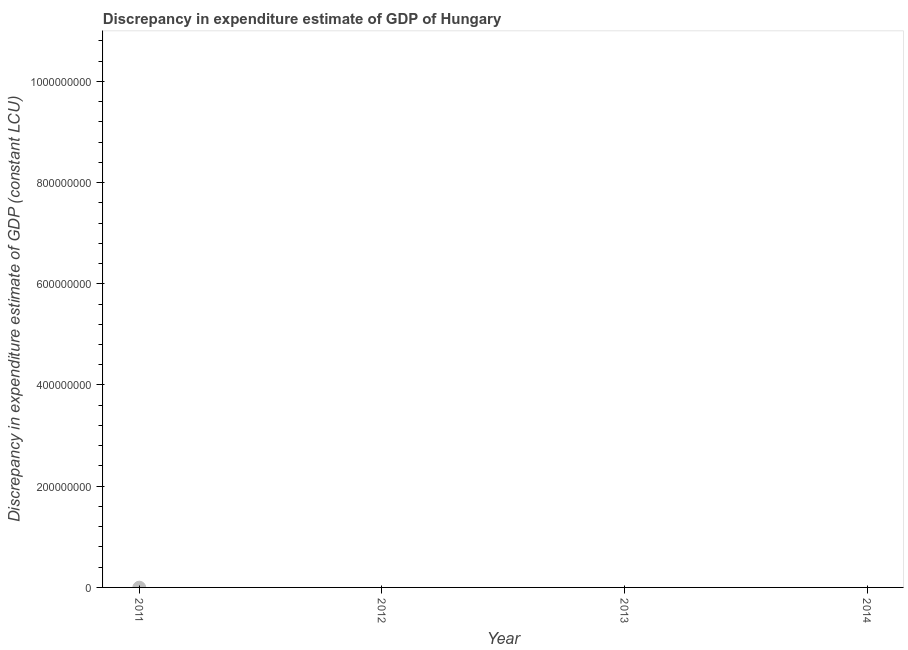Across all years, what is the minimum discrepancy in expenditure estimate of gdp?
Give a very brief answer. 0. What is the sum of the discrepancy in expenditure estimate of gdp?
Your answer should be compact. 0. What is the average discrepancy in expenditure estimate of gdp per year?
Your answer should be very brief. 0. What is the median discrepancy in expenditure estimate of gdp?
Your answer should be compact. 0. In how many years, is the discrepancy in expenditure estimate of gdp greater than the average discrepancy in expenditure estimate of gdp taken over all years?
Offer a very short reply. 0. How many dotlines are there?
Give a very brief answer. 0. What is the difference between two consecutive major ticks on the Y-axis?
Ensure brevity in your answer.  2.00e+08. Are the values on the major ticks of Y-axis written in scientific E-notation?
Keep it short and to the point. No. Does the graph contain any zero values?
Give a very brief answer. Yes. Does the graph contain grids?
Your answer should be very brief. No. What is the title of the graph?
Keep it short and to the point. Discrepancy in expenditure estimate of GDP of Hungary. What is the label or title of the X-axis?
Keep it short and to the point. Year. What is the label or title of the Y-axis?
Offer a very short reply. Discrepancy in expenditure estimate of GDP (constant LCU). What is the Discrepancy in expenditure estimate of GDP (constant LCU) in 2011?
Make the answer very short. 0. What is the Discrepancy in expenditure estimate of GDP (constant LCU) in 2013?
Give a very brief answer. 0. 